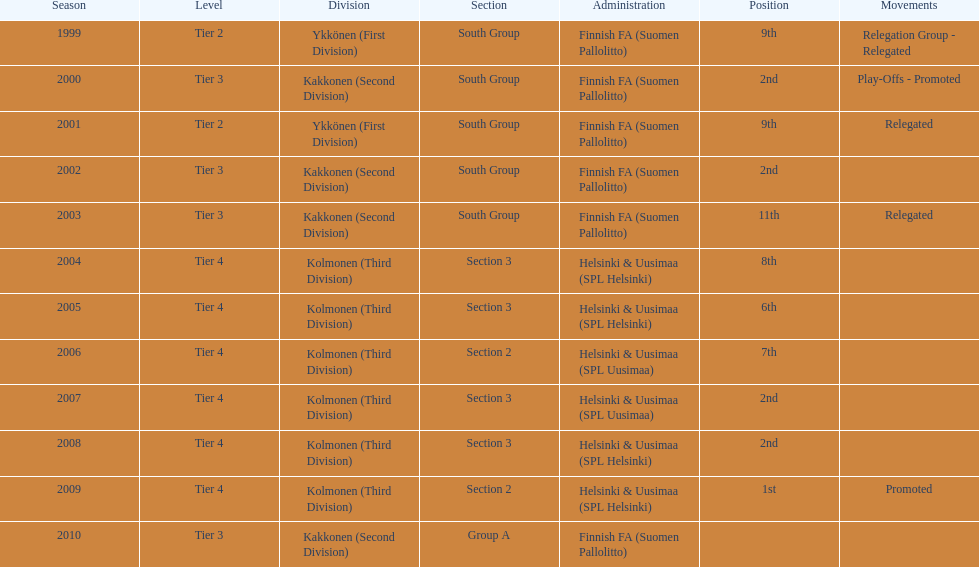What was the count of second-place finishes? 4. 